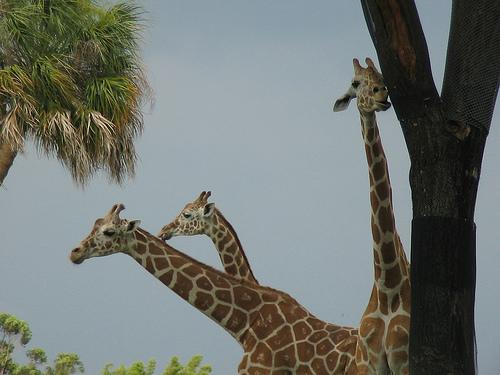In one sentence, convey the primary action or interaction occurring in the image. Three giraffes stand next to each other near a tree with green leaves and a brown trunk. Mention the key details of the picture, including the number of objects, their description, and the environment. Three giraffes with brown and white spots, green and brown tree, brown trunk, blue sky without clouds, and an overcast atmosphere. State the primary focus of the image and what makes it interesting. The image focuses on three giraffes standing close together, each with unique brown and white spots on their fur. Provide an overview of the scene including the primary and secondary elements present. The image depicts three giraffes standing near a tree with green leaves and a brown trunk, under an overcast, cloudless sky. Mention the primary object in the image along with its most distinguishing feature. There are three giraffes standing next to each other with brown and white spots on their fur. Describe the main subject's characteristics and the secondary subject's appearance. The main subject is a giraffe with brown spots, white ears, and a brown mane, while the secondary subject is a green tree with a brown trunk. Provide a brief description of the image focusing on the main subject and their surroundings. Three giraffes are standing close together near a tree with green leaves and a brown trunk, under a hazy blue sky. Identify the main object in the image and describe its physical appearance. The main object is a giraffe with a long neck, brown spots on its fur, white ears, and a brown mane. List the prominent subjects and objects found in the image. Three giraffes, green tree, brown trunk, brown spots, blue and hazy sky Describe the atmosphere of the image based on the environmental elements present. The image has an overcast sky with no clouds, and depicts three giraffes standing near a green tree with a brown trunk. 